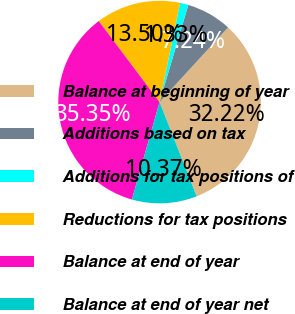Convert chart. <chart><loc_0><loc_0><loc_500><loc_500><pie_chart><fcel>Balance at beginning of year<fcel>Additions based on tax<fcel>Additions for tax positions of<fcel>Reductions for tax positions<fcel>Balance at end of year<fcel>Balance at end of year net<nl><fcel>32.22%<fcel>7.24%<fcel>1.33%<fcel>13.5%<fcel>35.35%<fcel>10.37%<nl></chart> 